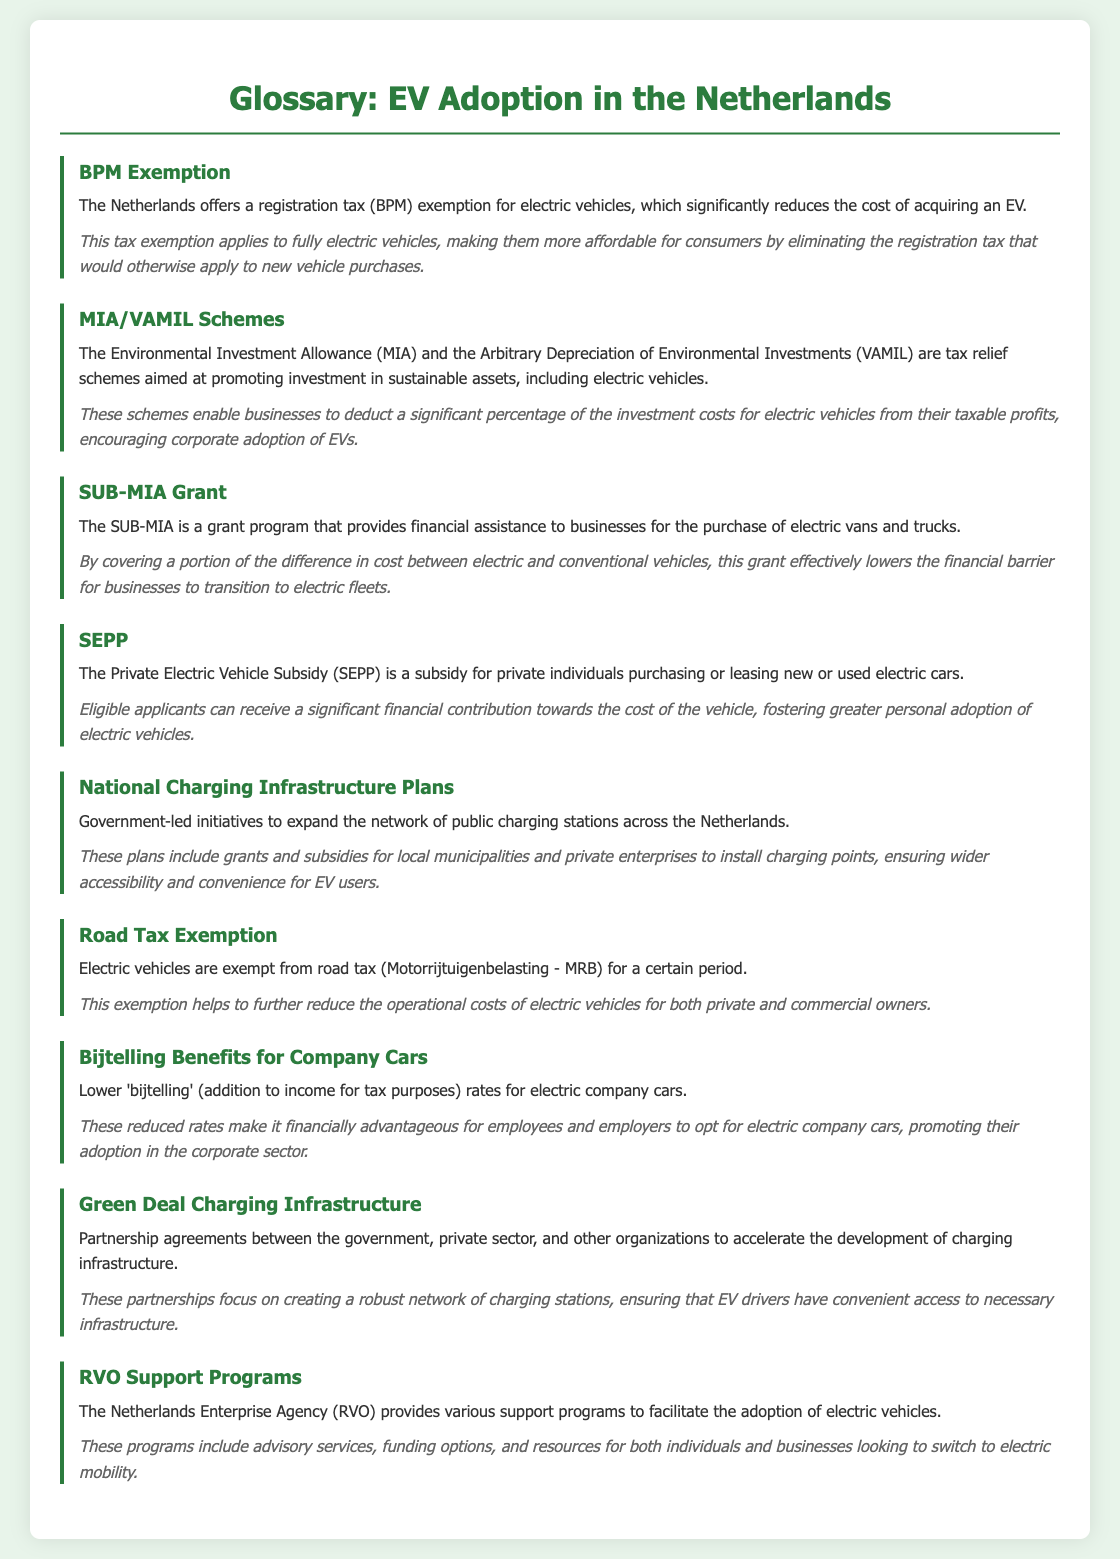What is BPM Exemption? BPM Exemption refers to the registration tax exemption for electric vehicles in the Netherlands, which significantly reduces the cost of acquiring an EV.
Answer: registration tax exemption What does MIA stand for? MIA stands for Environmental Investment Allowance, which is part of tax relief schemes aimed at promoting investment in sustainable assets, including electric vehicles.
Answer: Environmental Investment Allowance What is the purpose of the SUB-MIA Grant? The SUB-MIA Grant provides financial assistance to businesses for the purchase of electric vans and trucks, effectively lowering the financial barrier for transitioning to electric fleets.
Answer: financial assistance for electric vans and trucks Who is eligible for the SEPP subsidy? Individuals purchasing or leasing new or used electric cars are eligible for the Private Electric Vehicle Subsidy (SEPP).
Answer: private individuals What is the impact of Road Tax Exemption? The Road Tax Exemption reduces the operational costs of electric vehicles for both private and commercial owners for a certain period.
Answer: reduces operational costs How do Bijtelling Benefits affect company cars? Lower 'bijtelling' rates for electric company cars make it financially advantageous for employees and employers, promoting their adoption in the corporate sector.
Answer: financially advantageous What are National Charging Infrastructure Plans? National Charging Infrastructure Plans are government-led initiatives to expand the network of public charging stations across the Netherlands.
Answer: expand public charging stations What type of support does RVO provide? RVO provides various support programs, including advisory services, funding options, and resources to facilitate the adoption of electric vehicles.
Answer: advisory services and funding options What is the Green Deal Charging Infrastructure? Green Deal Charging Infrastructure refers to partnership agreements to accelerate the development of charging infrastructure involving the government and private sector.
Answer: partnership agreements for charging infrastructure 